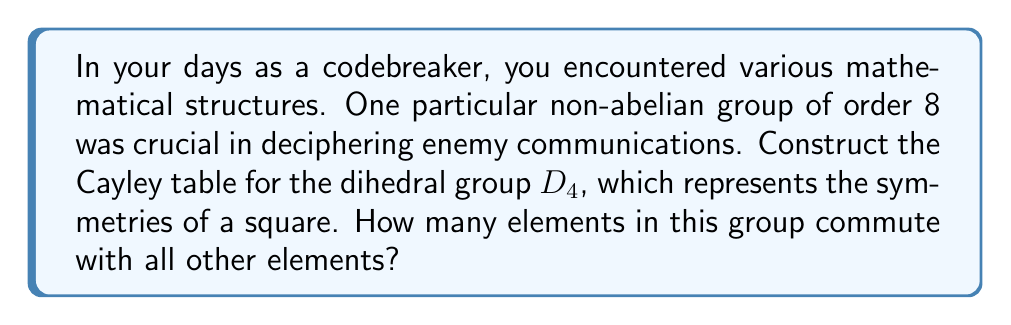Help me with this question. Let's approach this step-by-step:

1) First, we need to understand the elements of $D_4$:
   - The identity element $e$
   - Three rotations: $r$ (90°), $r^2$ (180°), $r^3$ (270°)
   - Four reflections: $s$ (vertical), $sr$ (diagonal), $sr^2$ (horizontal), $sr^3$ (other diagonal)

2) Now, let's construct the Cayley table:

   $$\begin{array}{c|cccccccc}
   * & e & r & r^2 & r^3 & s & sr & sr^2 & sr^3 \\
   \hline
   e & e & r & r^2 & r^3 & s & sr & sr^2 & sr^3 \\
   r & r & r^2 & r^3 & e & sr & sr^2 & sr^3 & s \\
   r^2 & r^2 & r^3 & e & r & sr^2 & sr^3 & s & sr \\
   r^3 & r^3 & e & r & r^2 & sr^3 & s & sr & sr^2 \\
   s & s & sr^3 & sr^2 & sr & e & r^3 & r^2 & r \\
   sr & sr & s & sr^3 & sr^2 & r & e & r^3 & r^2 \\
   sr^2 & sr^2 & sr & s & sr^3 & r^2 & r & e & r^3 \\
   sr^3 & sr^3 & sr^2 & sr & s & r^3 & r^2 & r & e
   \end{array}$$

3) To find how many elements commute with all other elements, we need to check which rows in the table are identical to their corresponding columns.

4) We can see that only the row for $e$ and the row for $r^2$ are identical to their corresponding columns.

5) This means that only $e$ and $r^2$ commute with all other elements in the group.

Therefore, there are 2 elements in $D_4$ that commute with all other elements.
Answer: 2 elements 